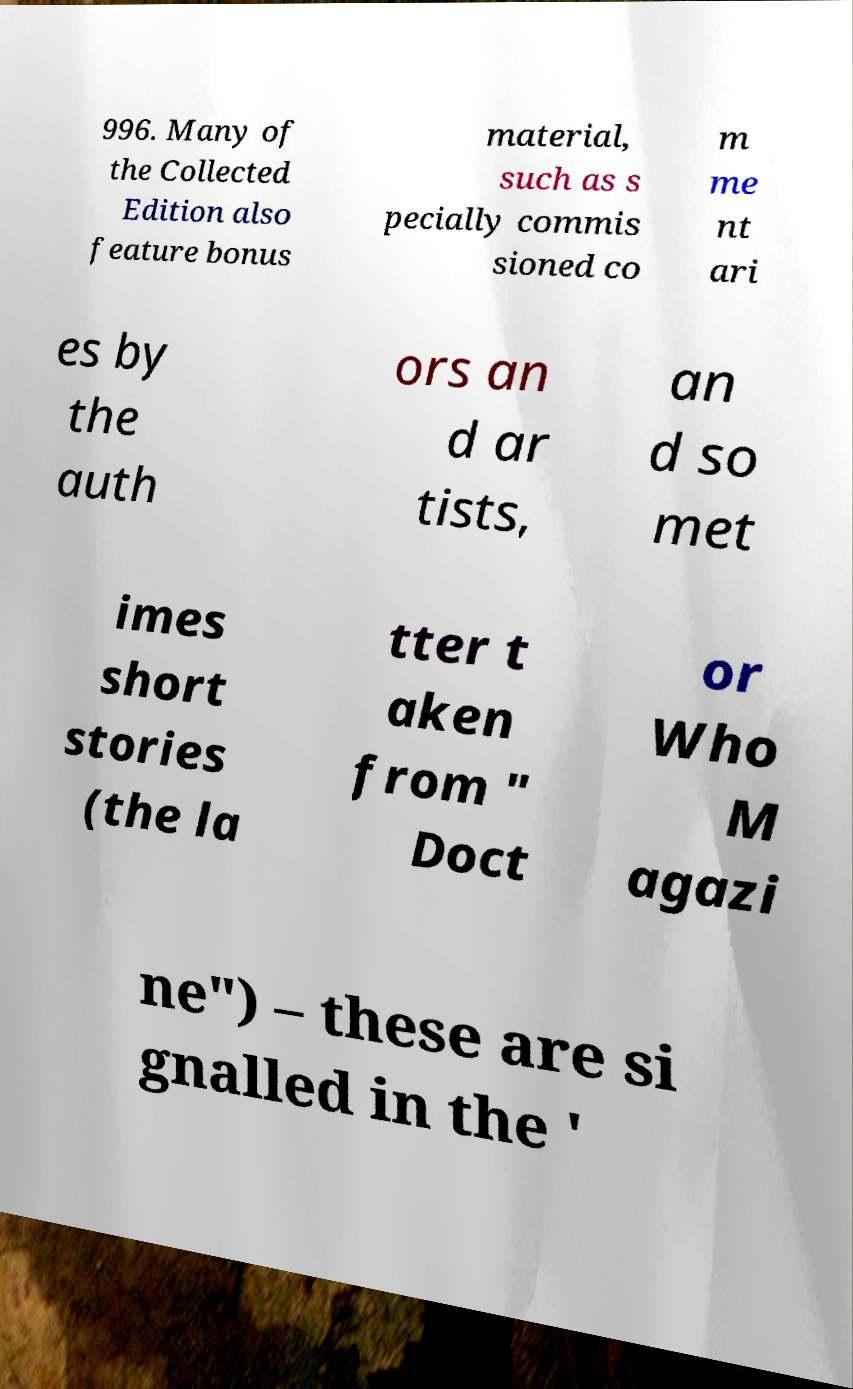Could you assist in decoding the text presented in this image and type it out clearly? 996. Many of the Collected Edition also feature bonus material, such as s pecially commis sioned co m me nt ari es by the auth ors an d ar tists, an d so met imes short stories (the la tter t aken from " Doct or Who M agazi ne") – these are si gnalled in the ' 